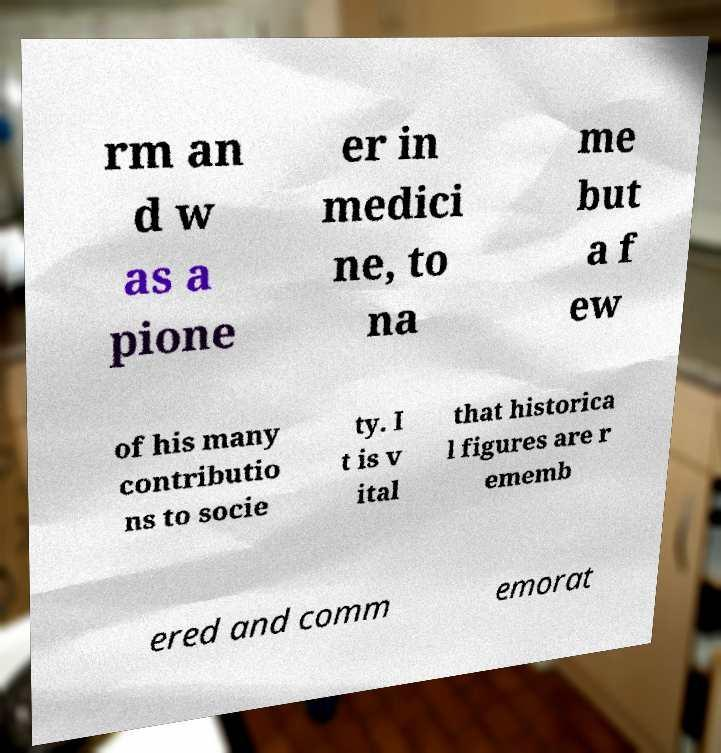Can you read and provide the text displayed in the image?This photo seems to have some interesting text. Can you extract and type it out for me? rm an d w as a pione er in medici ne, to na me but a f ew of his many contributio ns to socie ty. I t is v ital that historica l figures are r ememb ered and comm emorat 